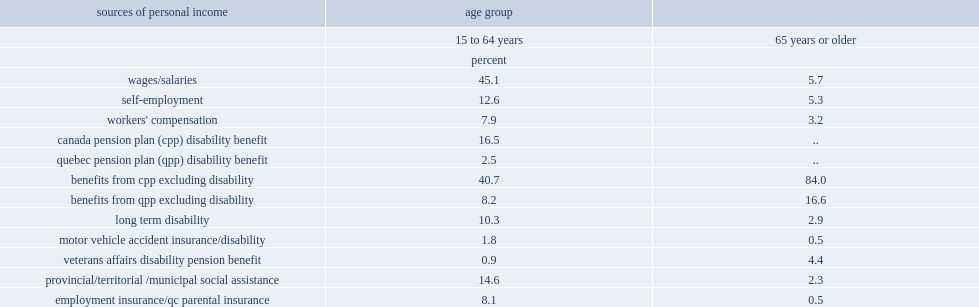What is the percentage of people who report income from wages and salaries at ages 15 to 64 years? 45.1. What is the percentage of people who report income from receiving cpp benefits excluding disability at ages 15 to 64 years? 40.7. What is the percentage of people who report income from provincial/territorial/municipal social assistance at ages 15 to 64 years? 14.6. What is the percentage of people who report income from wages and salaries at ages 65 years or older? 5.7. What is the percentage of people who report income from receiving cpp benefits excluding disability at ages 65 years or older? 84.0. What is the percentage of people who report income from provincial/territorial/municipal social assistance at ages 65 years or older? 2.3. 